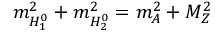Convert formula to latex. <formula><loc_0><loc_0><loc_500><loc_500>m _ { H _ { 1 } ^ { 0 } } ^ { 2 } + m _ { H _ { 2 } ^ { 0 } } ^ { 2 } = m _ { A } ^ { 2 } + M _ { Z } ^ { 2 }</formula> 